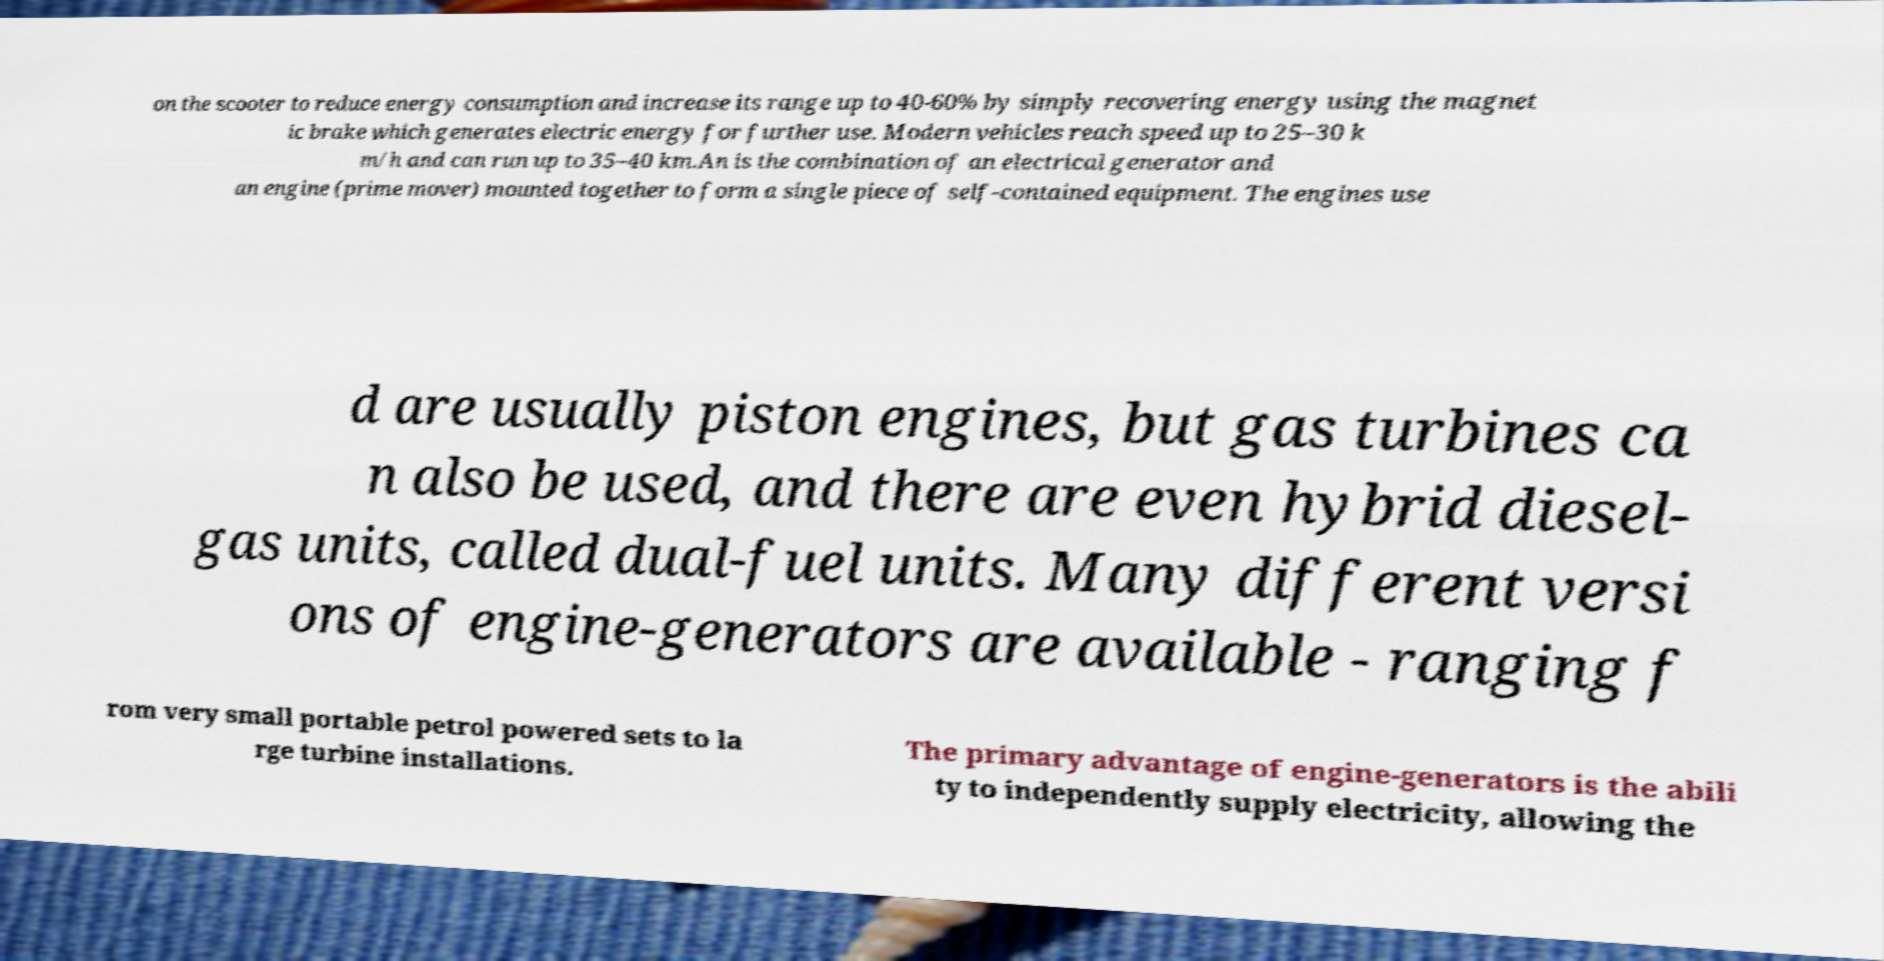Can you read and provide the text displayed in the image?This photo seems to have some interesting text. Can you extract and type it out for me? on the scooter to reduce energy consumption and increase its range up to 40-60% by simply recovering energy using the magnet ic brake which generates electric energy for further use. Modern vehicles reach speed up to 25–30 k m/h and can run up to 35–40 km.An is the combination of an electrical generator and an engine (prime mover) mounted together to form a single piece of self-contained equipment. The engines use d are usually piston engines, but gas turbines ca n also be used, and there are even hybrid diesel- gas units, called dual-fuel units. Many different versi ons of engine-generators are available - ranging f rom very small portable petrol powered sets to la rge turbine installations. The primary advantage of engine-generators is the abili ty to independently supply electricity, allowing the 